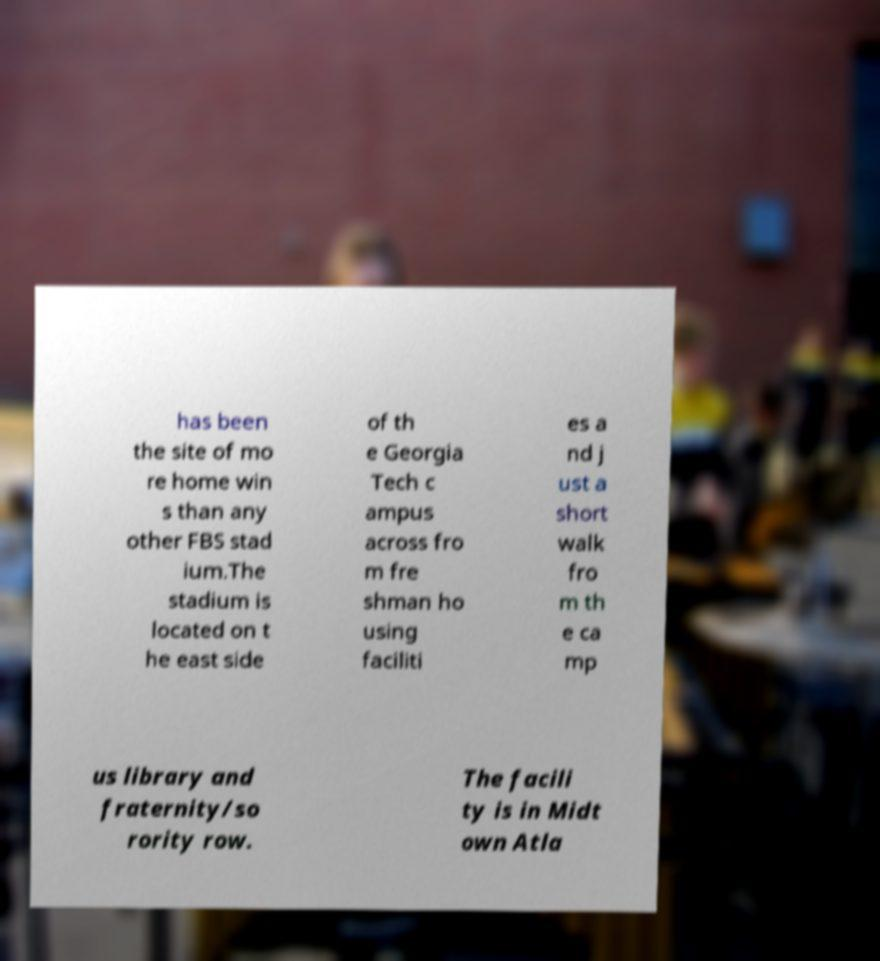Please read and relay the text visible in this image. What does it say? has been the site of mo re home win s than any other FBS stad ium.The stadium is located on t he east side of th e Georgia Tech c ampus across fro m fre shman ho using faciliti es a nd j ust a short walk fro m th e ca mp us library and fraternity/so rority row. The facili ty is in Midt own Atla 